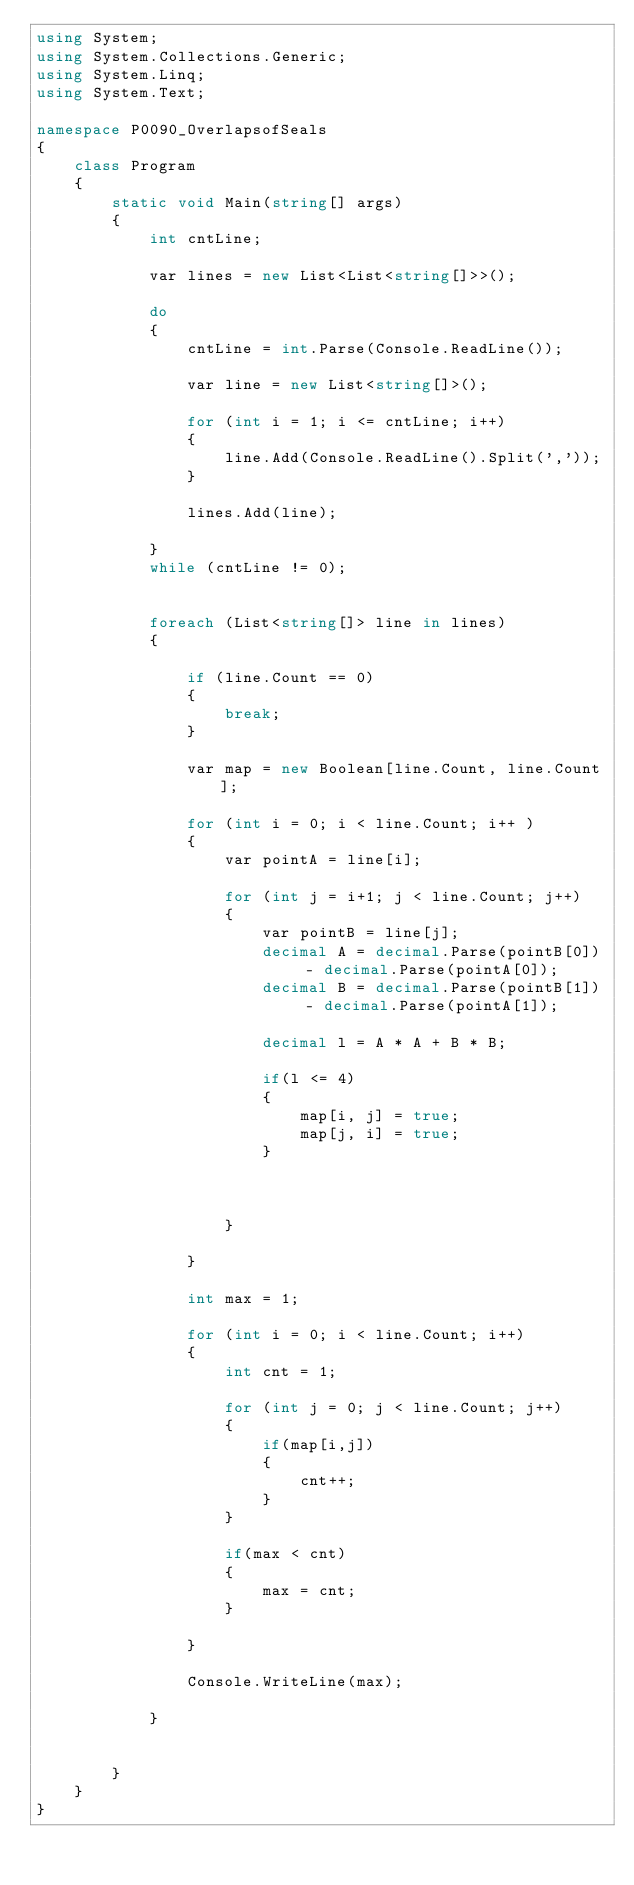<code> <loc_0><loc_0><loc_500><loc_500><_C#_>using System;
using System.Collections.Generic;
using System.Linq;
using System.Text;

namespace P0090_OverlapsofSeals
{
    class Program
    {
        static void Main(string[] args)
        {
            int cntLine;

            var lines = new List<List<string[]>>();

            do
            {
                cntLine = int.Parse(Console.ReadLine());

                var line = new List<string[]>();

                for (int i = 1; i <= cntLine; i++)
                {
                    line.Add(Console.ReadLine().Split(','));
                }

                lines.Add(line);

            }
            while (cntLine != 0);


            foreach (List<string[]> line in lines)
            {

                if (line.Count == 0)
                {
                    break;
                }

                var map = new Boolean[line.Count, line.Count];

                for (int i = 0; i < line.Count; i++ ) 
                {
                    var pointA = line[i];

                    for (int j = i+1; j < line.Count; j++)
                    {
                        var pointB = line[j];
                        decimal A = decimal.Parse(pointB[0]) - decimal.Parse(pointA[0]);
                        decimal B = decimal.Parse(pointB[1]) - decimal.Parse(pointA[1]);

                        decimal l = A * A + B * B;

                        if(l <= 4)
                        {
                            map[i, j] = true;
                            map[j, i] = true;
                        }

                        

                    }

                }

                int max = 1;

                for (int i = 0; i < line.Count; i++)
                {
                    int cnt = 1;

                    for (int j = 0; j < line.Count; j++)
                    {
                        if(map[i,j])
                        {
                            cnt++;
                        }
                    }

                    if(max < cnt)
                    {
                        max = cnt;
                    }

                }

                Console.WriteLine(max);

            }


        }
    }
}</code> 